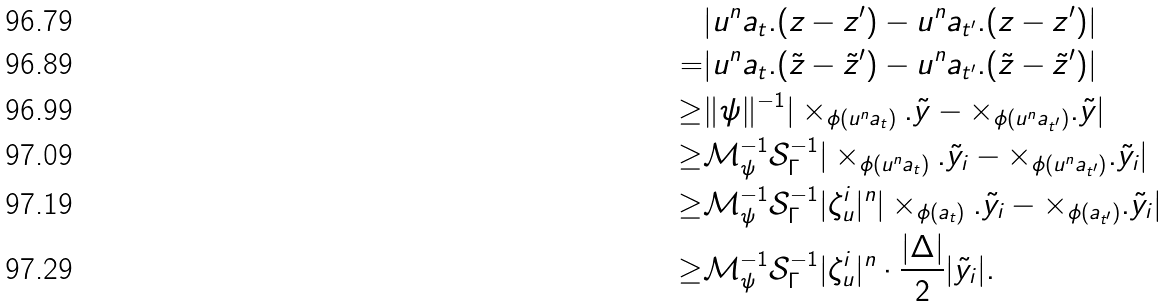Convert formula to latex. <formula><loc_0><loc_0><loc_500><loc_500>& | u ^ { n } a _ { t } . ( z - z ^ { \prime } ) - u ^ { n } a _ { t ^ { \prime } } . ( z - z ^ { \prime } ) | \\ = & | u ^ { n } a _ { t } . ( \tilde { z } - \tilde { z } ^ { \prime } ) - u ^ { n } a _ { t ^ { \prime } } . ( \tilde { z } - \tilde { z } ^ { \prime } ) | \\ \geq & \| \psi \| ^ { - 1 } | \times _ { \phi ( u ^ { n } a _ { t } ) } . \tilde { y } - \times _ { \phi ( u ^ { n } a _ { t ^ { \prime } } ) } . \tilde { y } | \\ \geq & \mathcal { M } _ { \psi } ^ { - 1 } \mathcal { S } _ { \Gamma } ^ { - 1 } | \times _ { \phi ( u ^ { n } a _ { t } ) } . \tilde { y } _ { i } - \times _ { \phi ( u ^ { n } a _ { t ^ { \prime } } ) } . \tilde { y } _ { i } | \\ \geq & \mathcal { M } _ { \psi } ^ { - 1 } \mathcal { S } _ { \Gamma } ^ { - 1 } | \zeta _ { u } ^ { i } | ^ { n } | \times _ { \phi ( a _ { t } ) } . \tilde { y } _ { i } - \times _ { \phi ( a _ { t ^ { \prime } } ) } . \tilde { y } _ { i } | \\ \geq & \mathcal { M } _ { \psi } ^ { - 1 } \mathcal { S } _ { \Gamma } ^ { - 1 } | \zeta _ { u } ^ { i } | ^ { n } \cdot \frac { | \Delta | } 2 | \tilde { y } _ { i } | .</formula> 